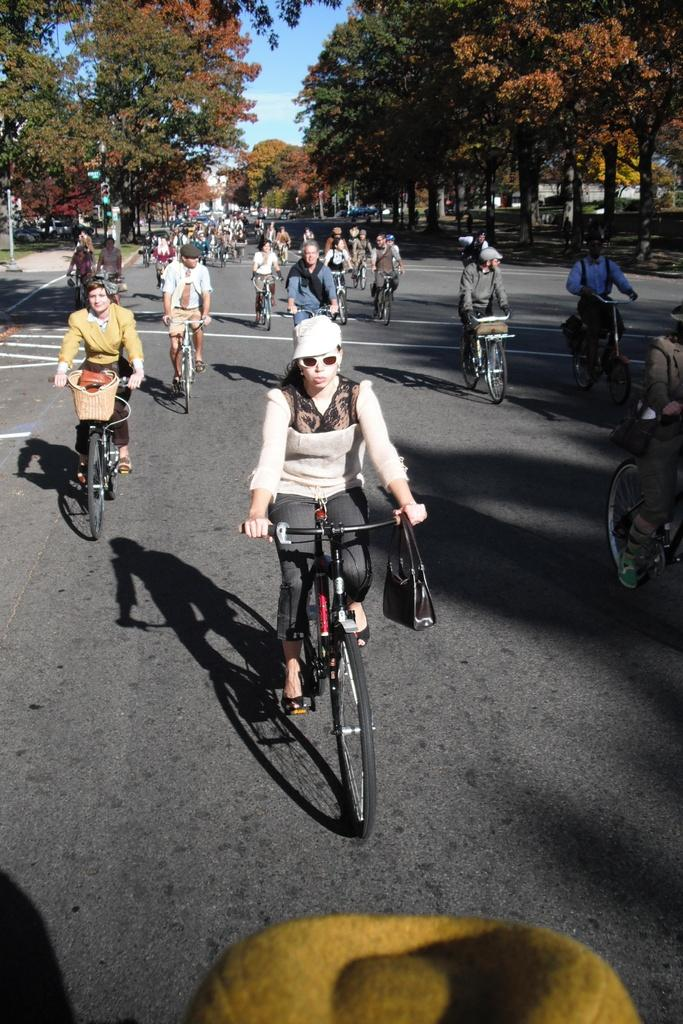What are the people in the image doing? The people in the image are riding bicycles. What can be seen in the background of the image? There are trees and the sky visible in the background of the image. What type of connection is being used by the bicycles in the image? There is no indication in the image that the bicycles are using any specific type of connection. Who is the expert in bicycle riding in the image? There is no specific person identified as an expert in bicycle riding in the image. 